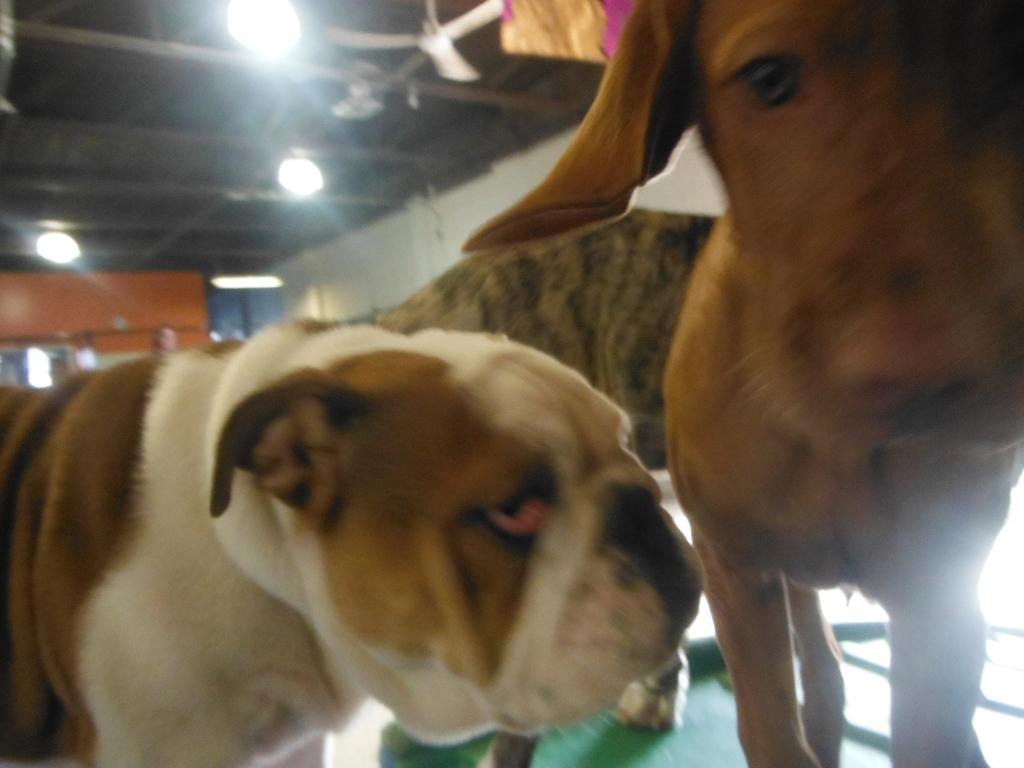What animals are standing on the floor in the image? There are dogs standing on the floor in the image. What can be seen in the background of the image? There is a ceiling fan, grills, and electric lights in the background of the image. Where is the toad sitting in the image? There is no toad present in the image. What type of lift can be seen in the image? There is no lift present in the image. 